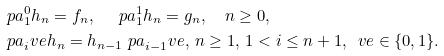Convert formula to latex. <formula><loc_0><loc_0><loc_500><loc_500>& \ p a _ { 1 } ^ { 0 } h _ { n } = f _ { n } , \quad \ p a _ { 1 } ^ { 1 } h _ { n } = g _ { n } , \quad n \geq 0 , \\ & \ p a _ { i } ^ { \ } v e h _ { n } = h _ { n - 1 } \ p a _ { i - 1 } ^ { \ } v e , \, n \geq 1 , \, 1 < i \leq n + 1 , \, \ v e \in \{ 0 , 1 \} .</formula> 